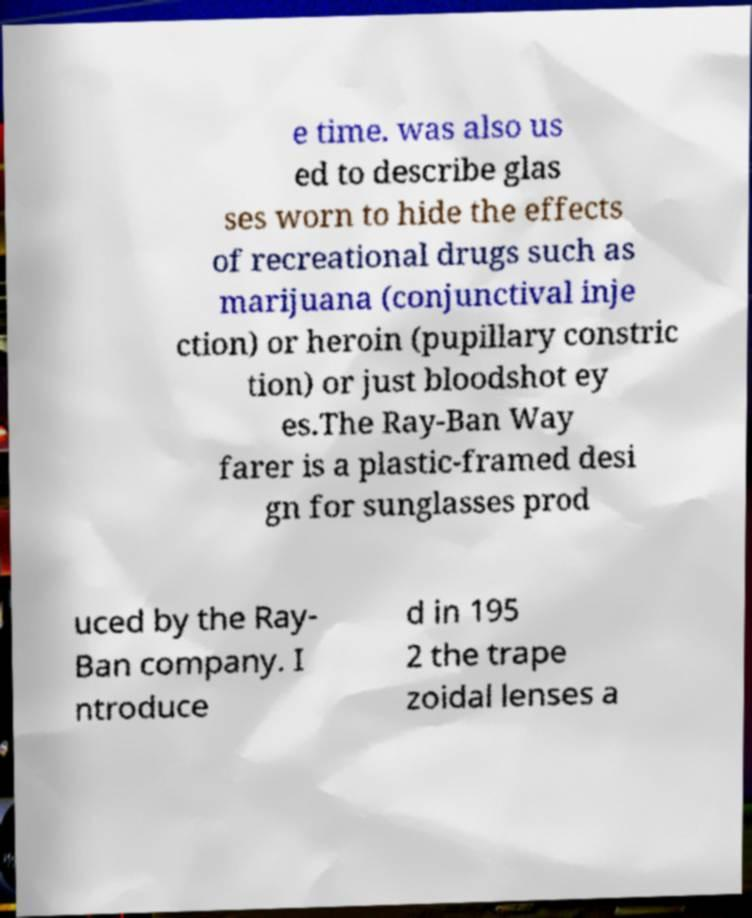Could you assist in decoding the text presented in this image and type it out clearly? e time. was also us ed to describe glas ses worn to hide the effects of recreational drugs such as marijuana (conjunctival inje ction) or heroin (pupillary constric tion) or just bloodshot ey es.The Ray-Ban Way farer is a plastic-framed desi gn for sunglasses prod uced by the Ray- Ban company. I ntroduce d in 195 2 the trape zoidal lenses a 